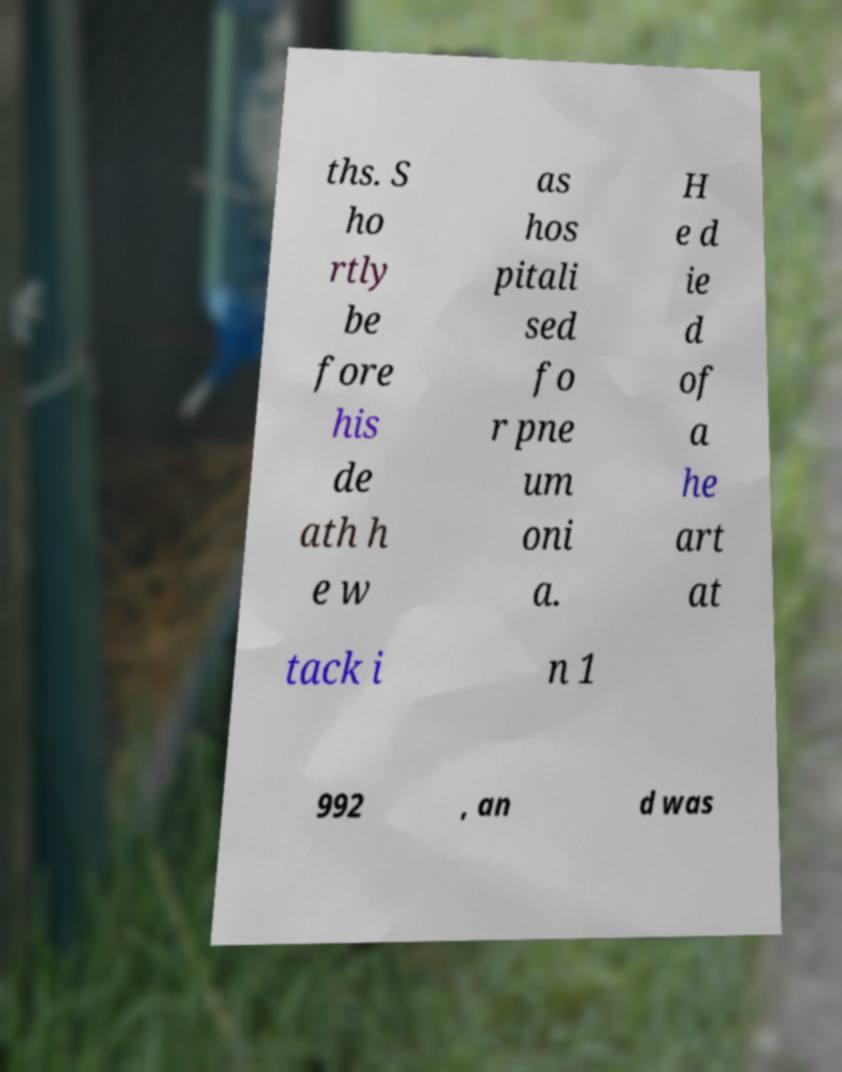Please identify and transcribe the text found in this image. ths. S ho rtly be fore his de ath h e w as hos pitali sed fo r pne um oni a. H e d ie d of a he art at tack i n 1 992 , an d was 